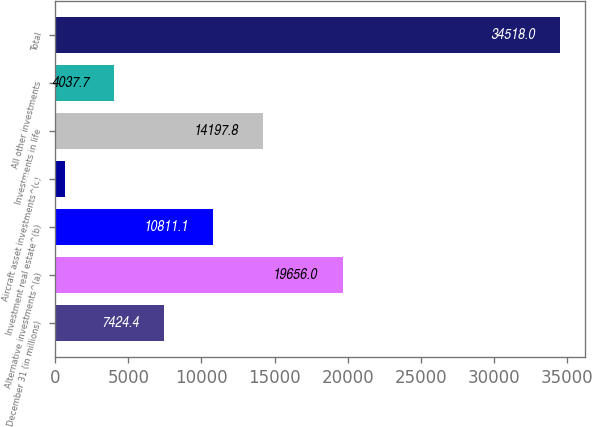Convert chart. <chart><loc_0><loc_0><loc_500><loc_500><bar_chart><fcel>December 31 (in millions)<fcel>Alternative investments^(a)<fcel>Investment real estate^(b)<fcel>Aircraft asset investments^(c)<fcel>Investments in life<fcel>All other investments<fcel>Total<nl><fcel>7424.4<fcel>19656<fcel>10811.1<fcel>651<fcel>14197.8<fcel>4037.7<fcel>34518<nl></chart> 